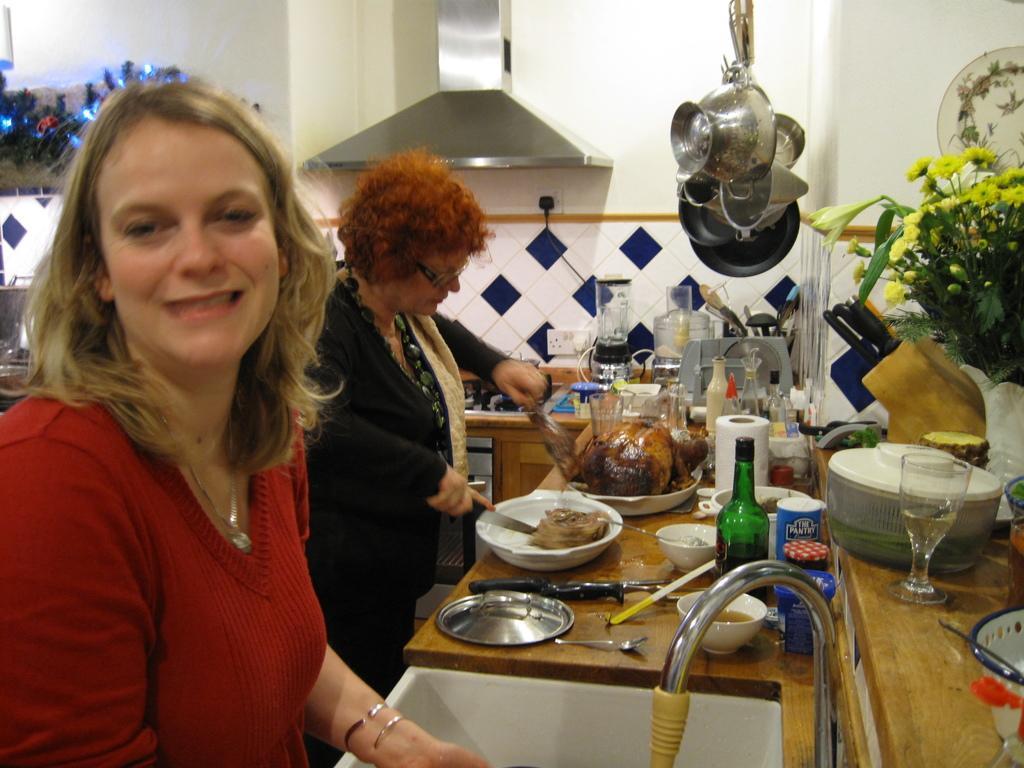Describe this image in one or two sentences. As we can see in the image there is a white color wall, sink and tap. There are two persons standing, bowls, dishes, bottles, tiles, decorative items and yellow color flowers. The woman standing in the front is wearing red color dress and the woman beside her is wearing black color dress. 